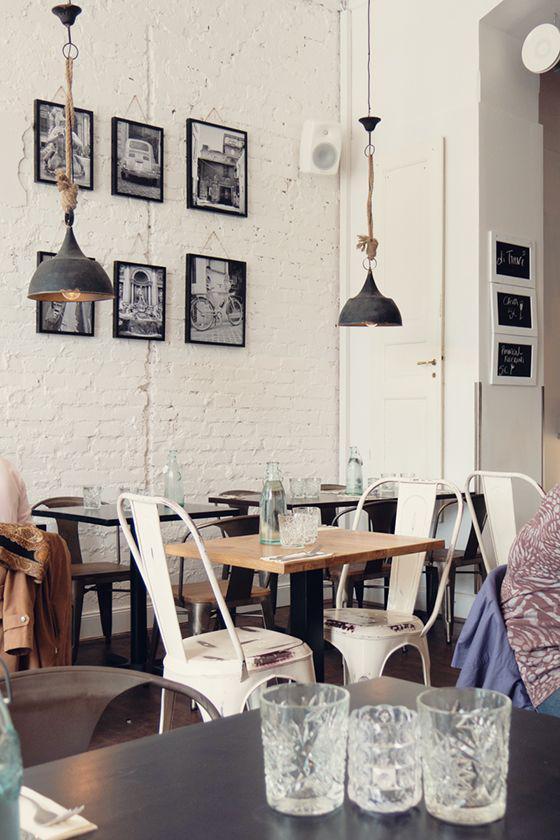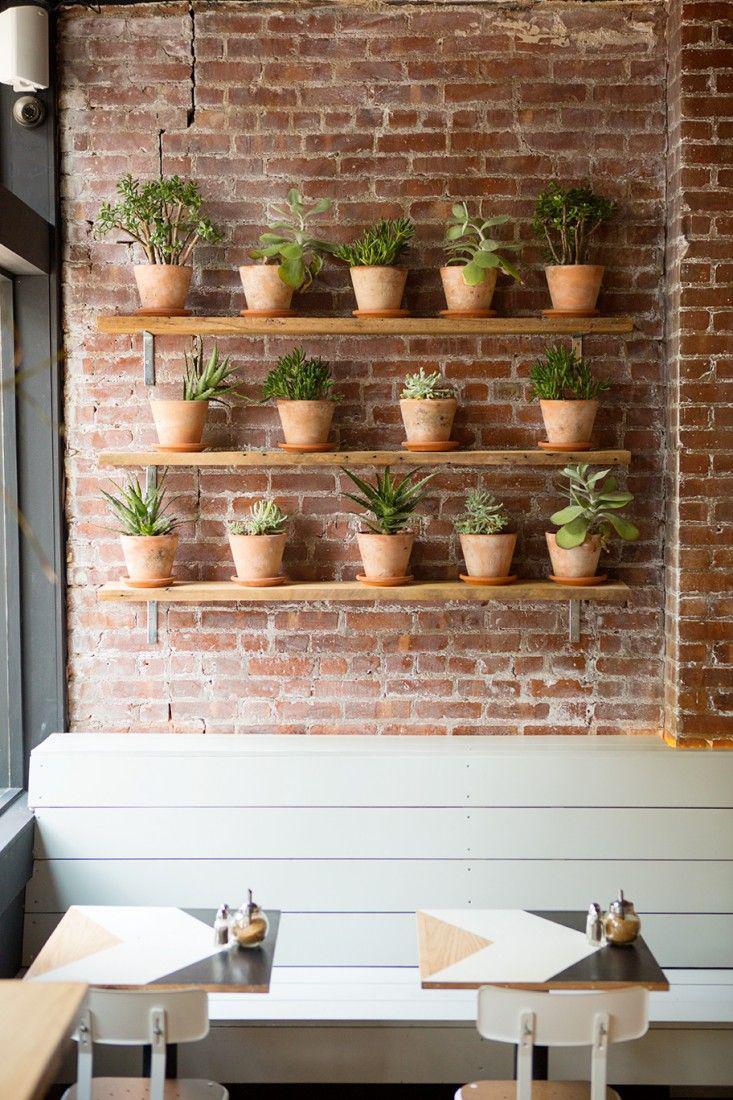The first image is the image on the left, the second image is the image on the right. Analyze the images presented: Is the assertion "Some of the white chairs are made of metal." valid? Answer yes or no. Yes. The first image is the image on the left, the second image is the image on the right. For the images displayed, is the sentence "Each image shows a cafe with seating on white chairs near an interior brick wall, but potted plants are in only one image." factually correct? Answer yes or no. Yes. 